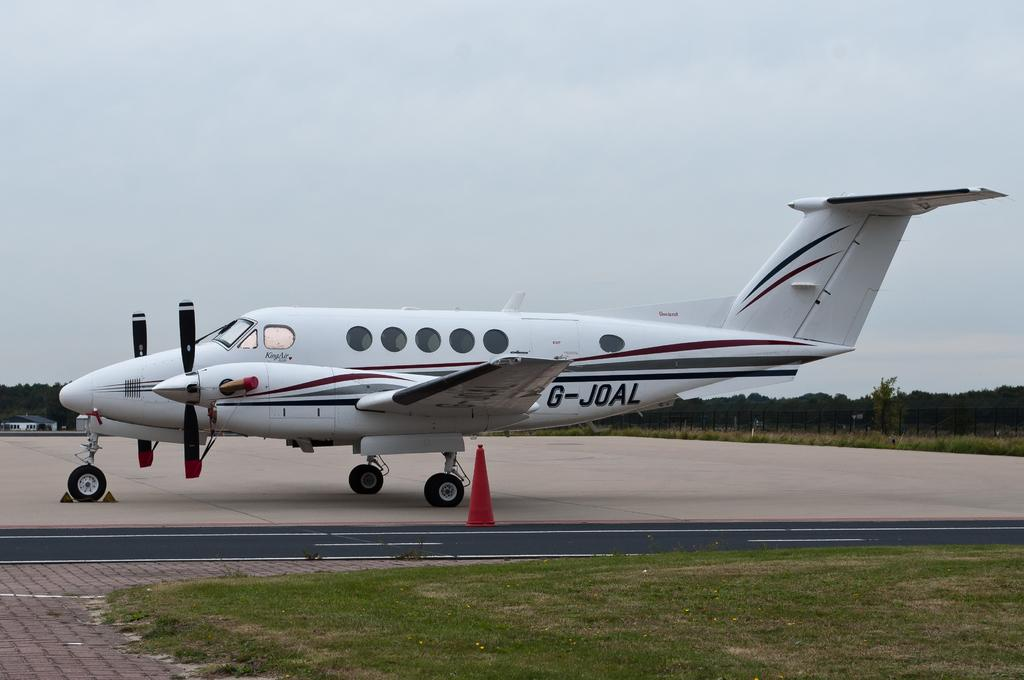<image>
Write a terse but informative summary of the picture. G Joal airplane that is on land and not flying 